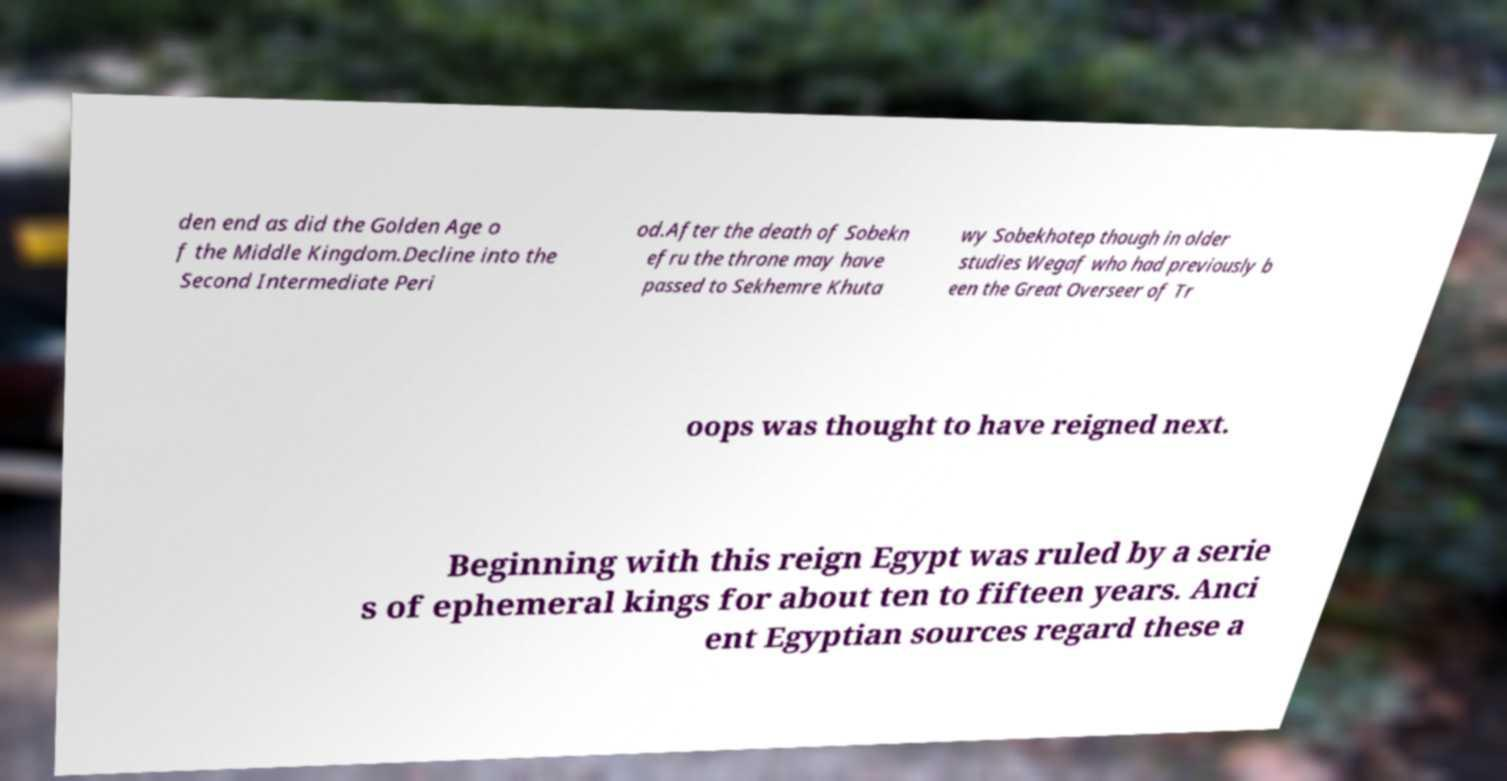Can you accurately transcribe the text from the provided image for me? den end as did the Golden Age o f the Middle Kingdom.Decline into the Second Intermediate Peri od.After the death of Sobekn efru the throne may have passed to Sekhemre Khuta wy Sobekhotep though in older studies Wegaf who had previously b een the Great Overseer of Tr oops was thought to have reigned next. Beginning with this reign Egypt was ruled by a serie s of ephemeral kings for about ten to fifteen years. Anci ent Egyptian sources regard these a 